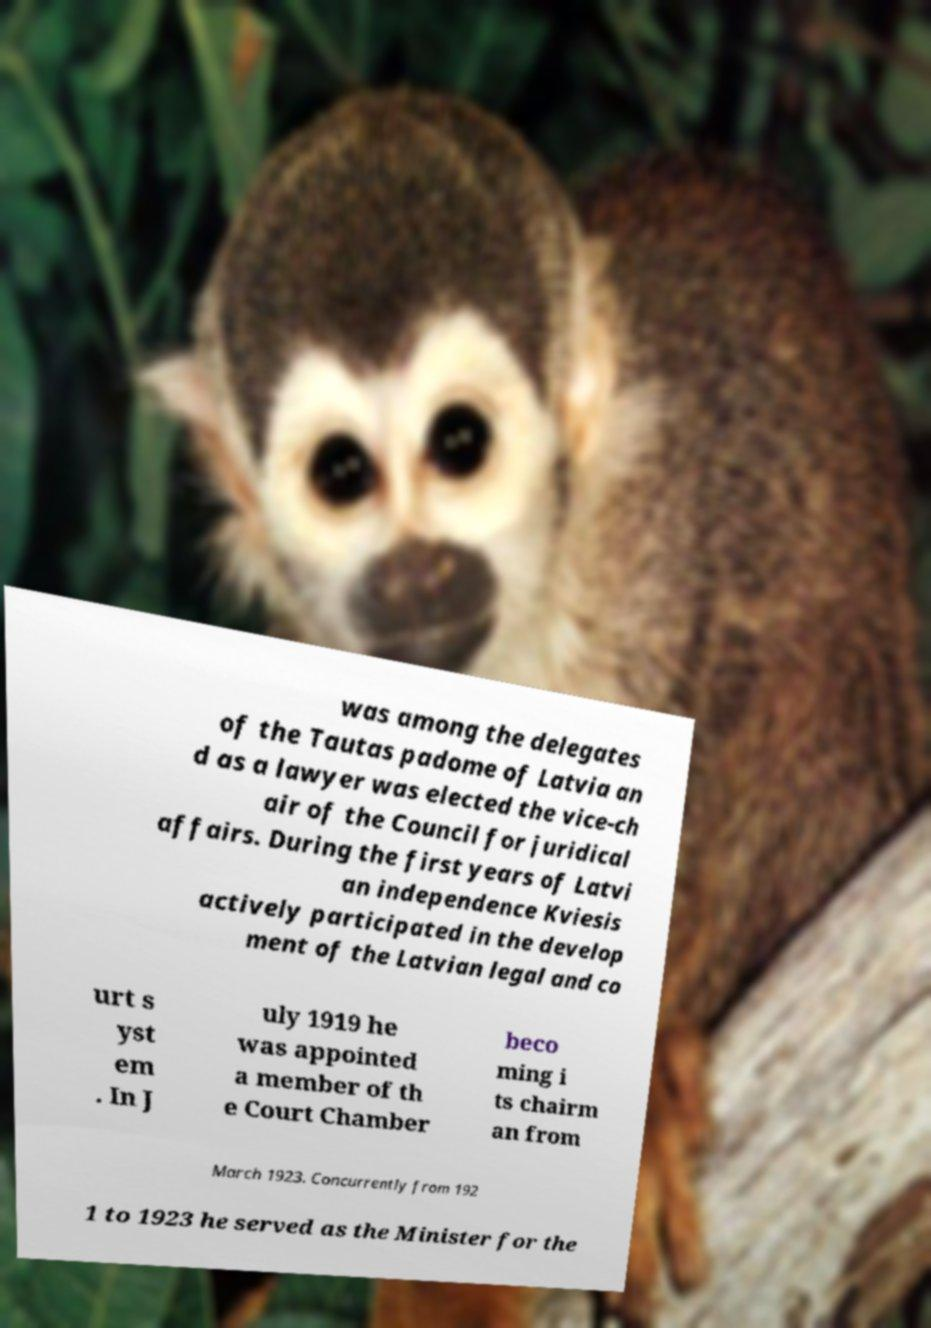Could you assist in decoding the text presented in this image and type it out clearly? was among the delegates of the Tautas padome of Latvia an d as a lawyer was elected the vice-ch air of the Council for juridical affairs. During the first years of Latvi an independence Kviesis actively participated in the develop ment of the Latvian legal and co urt s yst em . In J uly 1919 he was appointed a member of th e Court Chamber beco ming i ts chairm an from March 1923. Concurrently from 192 1 to 1923 he served as the Minister for the 